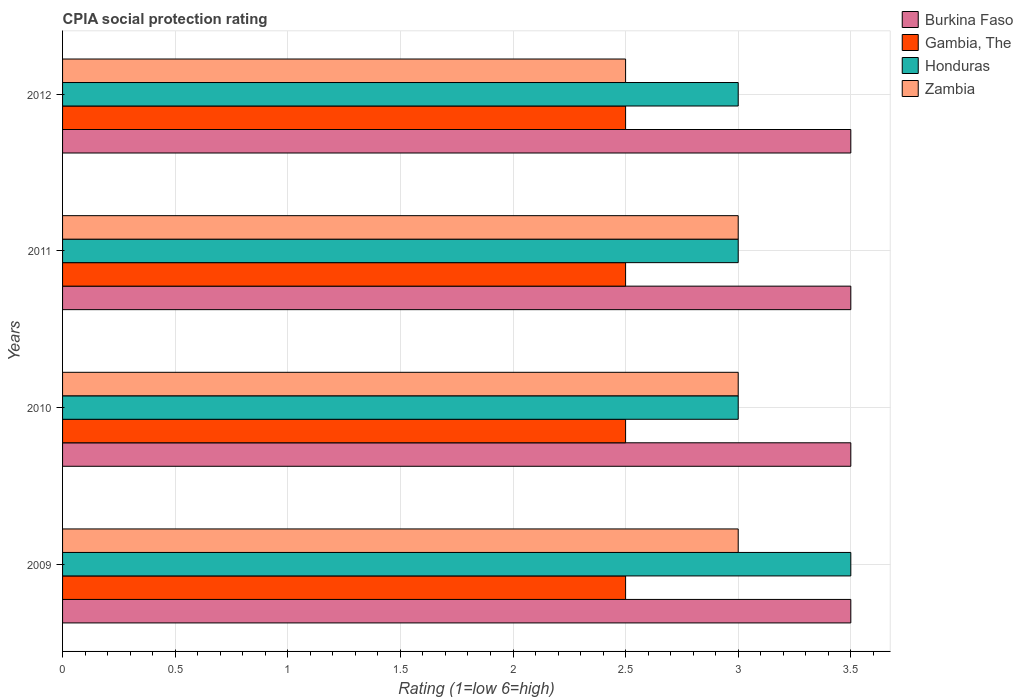Are the number of bars per tick equal to the number of legend labels?
Provide a succinct answer. Yes. What is the label of the 3rd group of bars from the top?
Offer a very short reply. 2010. In how many cases, is the number of bars for a given year not equal to the number of legend labels?
Offer a very short reply. 0. What is the CPIA rating in Gambia, The in 2011?
Provide a succinct answer. 2.5. In which year was the CPIA rating in Zambia maximum?
Give a very brief answer. 2009. In which year was the CPIA rating in Gambia, The minimum?
Your response must be concise. 2009. What is the total CPIA rating in Burkina Faso in the graph?
Keep it short and to the point. 14. What is the difference between the CPIA rating in Burkina Faso in 2009 and that in 2012?
Your response must be concise. 0. What is the difference between the CPIA rating in Zambia in 2009 and the CPIA rating in Gambia, The in 2012?
Your answer should be compact. 0.5. What is the average CPIA rating in Gambia, The per year?
Ensure brevity in your answer.  2.5. In the year 2009, what is the difference between the CPIA rating in Honduras and CPIA rating in Burkina Faso?
Your answer should be very brief. 0. What is the difference between the highest and the second highest CPIA rating in Honduras?
Your answer should be very brief. 0.5. What is the difference between the highest and the lowest CPIA rating in Gambia, The?
Offer a terse response. 0. Is it the case that in every year, the sum of the CPIA rating in Zambia and CPIA rating in Gambia, The is greater than the sum of CPIA rating in Burkina Faso and CPIA rating in Honduras?
Offer a very short reply. No. What does the 4th bar from the top in 2012 represents?
Your response must be concise. Burkina Faso. What does the 2nd bar from the bottom in 2009 represents?
Provide a succinct answer. Gambia, The. How many bars are there?
Give a very brief answer. 16. Are all the bars in the graph horizontal?
Your answer should be very brief. Yes. Are the values on the major ticks of X-axis written in scientific E-notation?
Your response must be concise. No. Does the graph contain any zero values?
Your answer should be compact. No. Does the graph contain grids?
Give a very brief answer. Yes. What is the title of the graph?
Offer a terse response. CPIA social protection rating. What is the label or title of the X-axis?
Offer a terse response. Rating (1=low 6=high). What is the label or title of the Y-axis?
Your answer should be very brief. Years. What is the Rating (1=low 6=high) of Burkina Faso in 2009?
Keep it short and to the point. 3.5. What is the Rating (1=low 6=high) of Gambia, The in 2009?
Your response must be concise. 2.5. What is the Rating (1=low 6=high) in Zambia in 2009?
Your answer should be compact. 3. What is the Rating (1=low 6=high) in Zambia in 2010?
Provide a succinct answer. 3. What is the Rating (1=low 6=high) of Burkina Faso in 2011?
Offer a terse response. 3.5. What is the Rating (1=low 6=high) of Honduras in 2011?
Offer a terse response. 3. What is the Rating (1=low 6=high) in Gambia, The in 2012?
Offer a terse response. 2.5. Across all years, what is the maximum Rating (1=low 6=high) of Gambia, The?
Make the answer very short. 2.5. Across all years, what is the maximum Rating (1=low 6=high) of Honduras?
Offer a terse response. 3.5. What is the total Rating (1=low 6=high) in Honduras in the graph?
Your answer should be very brief. 12.5. What is the total Rating (1=low 6=high) in Zambia in the graph?
Offer a very short reply. 11.5. What is the difference between the Rating (1=low 6=high) of Burkina Faso in 2009 and that in 2010?
Your answer should be compact. 0. What is the difference between the Rating (1=low 6=high) in Gambia, The in 2009 and that in 2010?
Give a very brief answer. 0. What is the difference between the Rating (1=low 6=high) of Honduras in 2009 and that in 2010?
Provide a succinct answer. 0.5. What is the difference between the Rating (1=low 6=high) in Burkina Faso in 2009 and that in 2011?
Make the answer very short. 0. What is the difference between the Rating (1=low 6=high) in Honduras in 2009 and that in 2011?
Ensure brevity in your answer.  0.5. What is the difference between the Rating (1=low 6=high) of Zambia in 2009 and that in 2012?
Provide a short and direct response. 0.5. What is the difference between the Rating (1=low 6=high) of Burkina Faso in 2010 and that in 2011?
Make the answer very short. 0. What is the difference between the Rating (1=low 6=high) in Gambia, The in 2010 and that in 2011?
Your response must be concise. 0. What is the difference between the Rating (1=low 6=high) in Honduras in 2010 and that in 2011?
Ensure brevity in your answer.  0. What is the difference between the Rating (1=low 6=high) in Burkina Faso in 2010 and that in 2012?
Ensure brevity in your answer.  0. What is the difference between the Rating (1=low 6=high) in Gambia, The in 2010 and that in 2012?
Make the answer very short. 0. What is the difference between the Rating (1=low 6=high) of Zambia in 2010 and that in 2012?
Provide a succinct answer. 0.5. What is the difference between the Rating (1=low 6=high) in Gambia, The in 2011 and that in 2012?
Offer a very short reply. 0. What is the difference between the Rating (1=low 6=high) of Zambia in 2011 and that in 2012?
Offer a very short reply. 0.5. What is the difference between the Rating (1=low 6=high) of Burkina Faso in 2009 and the Rating (1=low 6=high) of Gambia, The in 2010?
Give a very brief answer. 1. What is the difference between the Rating (1=low 6=high) in Burkina Faso in 2009 and the Rating (1=low 6=high) in Honduras in 2010?
Provide a short and direct response. 0.5. What is the difference between the Rating (1=low 6=high) of Burkina Faso in 2009 and the Rating (1=low 6=high) of Zambia in 2010?
Offer a very short reply. 0.5. What is the difference between the Rating (1=low 6=high) in Burkina Faso in 2009 and the Rating (1=low 6=high) in Honduras in 2011?
Give a very brief answer. 0.5. What is the difference between the Rating (1=low 6=high) of Gambia, The in 2009 and the Rating (1=low 6=high) of Zambia in 2011?
Make the answer very short. -0.5. What is the difference between the Rating (1=low 6=high) of Honduras in 2009 and the Rating (1=low 6=high) of Zambia in 2011?
Your answer should be compact. 0.5. What is the difference between the Rating (1=low 6=high) in Burkina Faso in 2009 and the Rating (1=low 6=high) in Gambia, The in 2012?
Your answer should be compact. 1. What is the difference between the Rating (1=low 6=high) of Burkina Faso in 2009 and the Rating (1=low 6=high) of Honduras in 2012?
Your answer should be compact. 0.5. What is the difference between the Rating (1=low 6=high) of Gambia, The in 2009 and the Rating (1=low 6=high) of Honduras in 2012?
Provide a succinct answer. -0.5. What is the difference between the Rating (1=low 6=high) in Burkina Faso in 2010 and the Rating (1=low 6=high) in Gambia, The in 2011?
Provide a short and direct response. 1. What is the difference between the Rating (1=low 6=high) of Gambia, The in 2010 and the Rating (1=low 6=high) of Zambia in 2011?
Give a very brief answer. -0.5. What is the difference between the Rating (1=low 6=high) in Honduras in 2010 and the Rating (1=low 6=high) in Zambia in 2011?
Offer a very short reply. 0. What is the difference between the Rating (1=low 6=high) of Burkina Faso in 2010 and the Rating (1=low 6=high) of Zambia in 2012?
Your response must be concise. 1. What is the difference between the Rating (1=low 6=high) of Gambia, The in 2010 and the Rating (1=low 6=high) of Zambia in 2012?
Your response must be concise. 0. What is the difference between the Rating (1=low 6=high) of Burkina Faso in 2011 and the Rating (1=low 6=high) of Gambia, The in 2012?
Keep it short and to the point. 1. What is the difference between the Rating (1=low 6=high) of Burkina Faso in 2011 and the Rating (1=low 6=high) of Zambia in 2012?
Your response must be concise. 1. What is the difference between the Rating (1=low 6=high) of Gambia, The in 2011 and the Rating (1=low 6=high) of Honduras in 2012?
Give a very brief answer. -0.5. What is the difference between the Rating (1=low 6=high) in Gambia, The in 2011 and the Rating (1=low 6=high) in Zambia in 2012?
Your response must be concise. 0. What is the average Rating (1=low 6=high) in Burkina Faso per year?
Provide a succinct answer. 3.5. What is the average Rating (1=low 6=high) in Honduras per year?
Your response must be concise. 3.12. What is the average Rating (1=low 6=high) in Zambia per year?
Your answer should be very brief. 2.88. In the year 2009, what is the difference between the Rating (1=low 6=high) in Burkina Faso and Rating (1=low 6=high) in Gambia, The?
Make the answer very short. 1. In the year 2009, what is the difference between the Rating (1=low 6=high) of Burkina Faso and Rating (1=low 6=high) of Honduras?
Your answer should be very brief. 0. In the year 2009, what is the difference between the Rating (1=low 6=high) in Burkina Faso and Rating (1=low 6=high) in Zambia?
Give a very brief answer. 0.5. In the year 2009, what is the difference between the Rating (1=low 6=high) of Gambia, The and Rating (1=low 6=high) of Honduras?
Ensure brevity in your answer.  -1. In the year 2009, what is the difference between the Rating (1=low 6=high) of Honduras and Rating (1=low 6=high) of Zambia?
Your answer should be very brief. 0.5. In the year 2010, what is the difference between the Rating (1=low 6=high) of Burkina Faso and Rating (1=low 6=high) of Zambia?
Provide a succinct answer. 0.5. In the year 2010, what is the difference between the Rating (1=low 6=high) in Gambia, The and Rating (1=low 6=high) in Zambia?
Keep it short and to the point. -0.5. In the year 2011, what is the difference between the Rating (1=low 6=high) of Burkina Faso and Rating (1=low 6=high) of Gambia, The?
Offer a terse response. 1. In the year 2011, what is the difference between the Rating (1=low 6=high) of Burkina Faso and Rating (1=low 6=high) of Zambia?
Provide a succinct answer. 0.5. In the year 2011, what is the difference between the Rating (1=low 6=high) in Gambia, The and Rating (1=low 6=high) in Zambia?
Your answer should be very brief. -0.5. In the year 2012, what is the difference between the Rating (1=low 6=high) of Burkina Faso and Rating (1=low 6=high) of Gambia, The?
Your answer should be very brief. 1. In the year 2012, what is the difference between the Rating (1=low 6=high) of Burkina Faso and Rating (1=low 6=high) of Honduras?
Your answer should be very brief. 0.5. In the year 2012, what is the difference between the Rating (1=low 6=high) of Burkina Faso and Rating (1=low 6=high) of Zambia?
Offer a terse response. 1. What is the ratio of the Rating (1=low 6=high) of Honduras in 2009 to that in 2010?
Ensure brevity in your answer.  1.17. What is the ratio of the Rating (1=low 6=high) in Zambia in 2009 to that in 2010?
Your answer should be very brief. 1. What is the ratio of the Rating (1=low 6=high) of Gambia, The in 2009 to that in 2011?
Your response must be concise. 1. What is the ratio of the Rating (1=low 6=high) of Zambia in 2009 to that in 2011?
Provide a succinct answer. 1. What is the ratio of the Rating (1=low 6=high) in Burkina Faso in 2009 to that in 2012?
Offer a terse response. 1. What is the ratio of the Rating (1=low 6=high) in Zambia in 2009 to that in 2012?
Ensure brevity in your answer.  1.2. What is the ratio of the Rating (1=low 6=high) in Burkina Faso in 2010 to that in 2011?
Make the answer very short. 1. What is the ratio of the Rating (1=low 6=high) in Zambia in 2010 to that in 2011?
Give a very brief answer. 1. What is the ratio of the Rating (1=low 6=high) in Gambia, The in 2010 to that in 2012?
Keep it short and to the point. 1. What is the ratio of the Rating (1=low 6=high) in Honduras in 2010 to that in 2012?
Your answer should be very brief. 1. What is the ratio of the Rating (1=low 6=high) in Zambia in 2010 to that in 2012?
Provide a short and direct response. 1.2. What is the ratio of the Rating (1=low 6=high) of Burkina Faso in 2011 to that in 2012?
Offer a very short reply. 1. What is the ratio of the Rating (1=low 6=high) in Gambia, The in 2011 to that in 2012?
Your answer should be compact. 1. What is the ratio of the Rating (1=low 6=high) in Honduras in 2011 to that in 2012?
Offer a terse response. 1. What is the difference between the highest and the second highest Rating (1=low 6=high) in Honduras?
Your answer should be compact. 0.5. What is the difference between the highest and the lowest Rating (1=low 6=high) of Gambia, The?
Offer a very short reply. 0. What is the difference between the highest and the lowest Rating (1=low 6=high) in Honduras?
Ensure brevity in your answer.  0.5. 